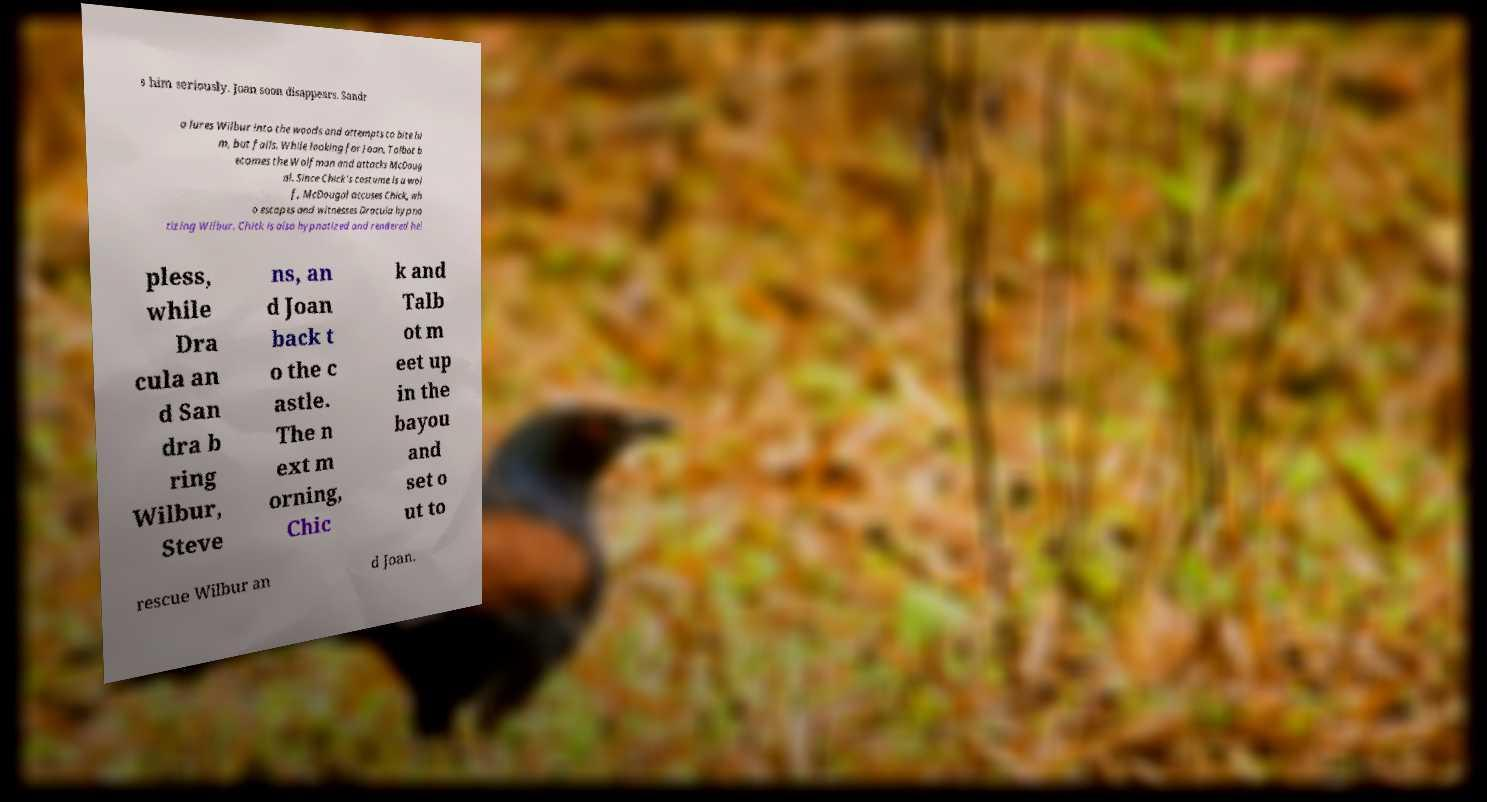Could you extract and type out the text from this image? s him seriously. Joan soon disappears. Sandr a lures Wilbur into the woods and attempts to bite hi m, but fails. While looking for Joan, Talbot b ecomes the Wolfman and attacks McDoug al. Since Chick's costume is a wol f, McDougal accuses Chick, wh o escapes and witnesses Dracula hypno tizing Wilbur. Chick is also hypnotized and rendered hel pless, while Dra cula an d San dra b ring Wilbur, Steve ns, an d Joan back t o the c astle. The n ext m orning, Chic k and Talb ot m eet up in the bayou and set o ut to rescue Wilbur an d Joan. 